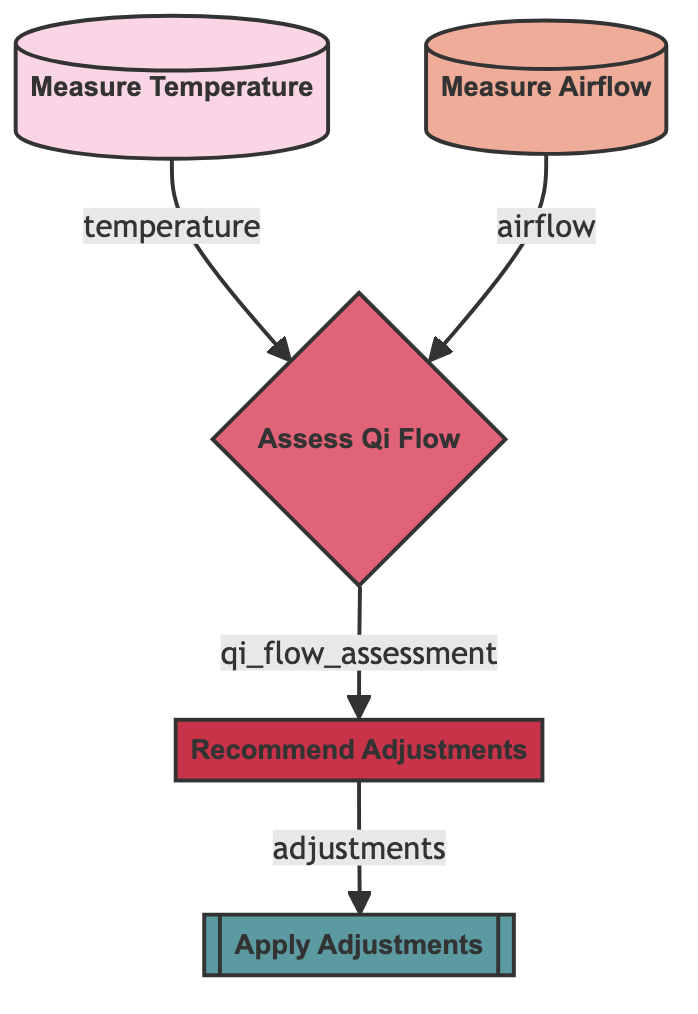what is the first step in the diagram? The first step in the diagram is measuring the temperature, as indicated by the node with the label "Measure Temperature" which does not have any incoming edges and initiates the flow.
Answer: Measure Temperature what is the output of the "measure_airflow" node? The output of the "measure_airflow" node is "airflow", which is specified in the elements of the flowchart as the result of that measurement node.
Answer: airflow how many nodes are there in the diagram? The diagram contains five nodes: "Measure Temperature," "Measure Airflow," "Assess Qi Flow," "Recommend Adjustments," and "Apply Adjustments," which can be counted from the list provided.
Answer: 5 which node takes both temperature and airflow as inputs? The node that takes both temperature and airflow as inputs is "Assess Qi Flow," as it is connected to both "Measure Temperature" and "Measure Airflow."
Answer: Assess Qi Flow what action is recommended after assessing Qi flow? After assessing Qi flow, the next recommended action is to "Recommend Adjustments," as indicated by the flow from the assessment node to the adjustments node.
Answer: Recommend Adjustments which node implements the recommended changes? The node that implements the recommended changes is "Apply Adjustments," as it is the final action in the flow after "Recommend Adjustments."
Answer: Apply Adjustments how many outputs does "assess_qi_flow" produce? The "assess_qi_flow" node produces one output, which is "qi_flow_assessment," clearly indicating its singular output in the structure of the flowchart.
Answer: 1 which step follows measuring the temperature? The step that follows measuring the temperature is "Assess Qi Flow," as the output from measuring temperature inputs into this node for evaluation.
Answer: Assess Qi Flow what are the inputs for the "recommend_adjustments" node? The inputs for the "recommend_adjustments" node are derived from the output of the "assess_qi_flow" node, which is "qi_flow_assessment."
Answer: qi_flow_assessment 